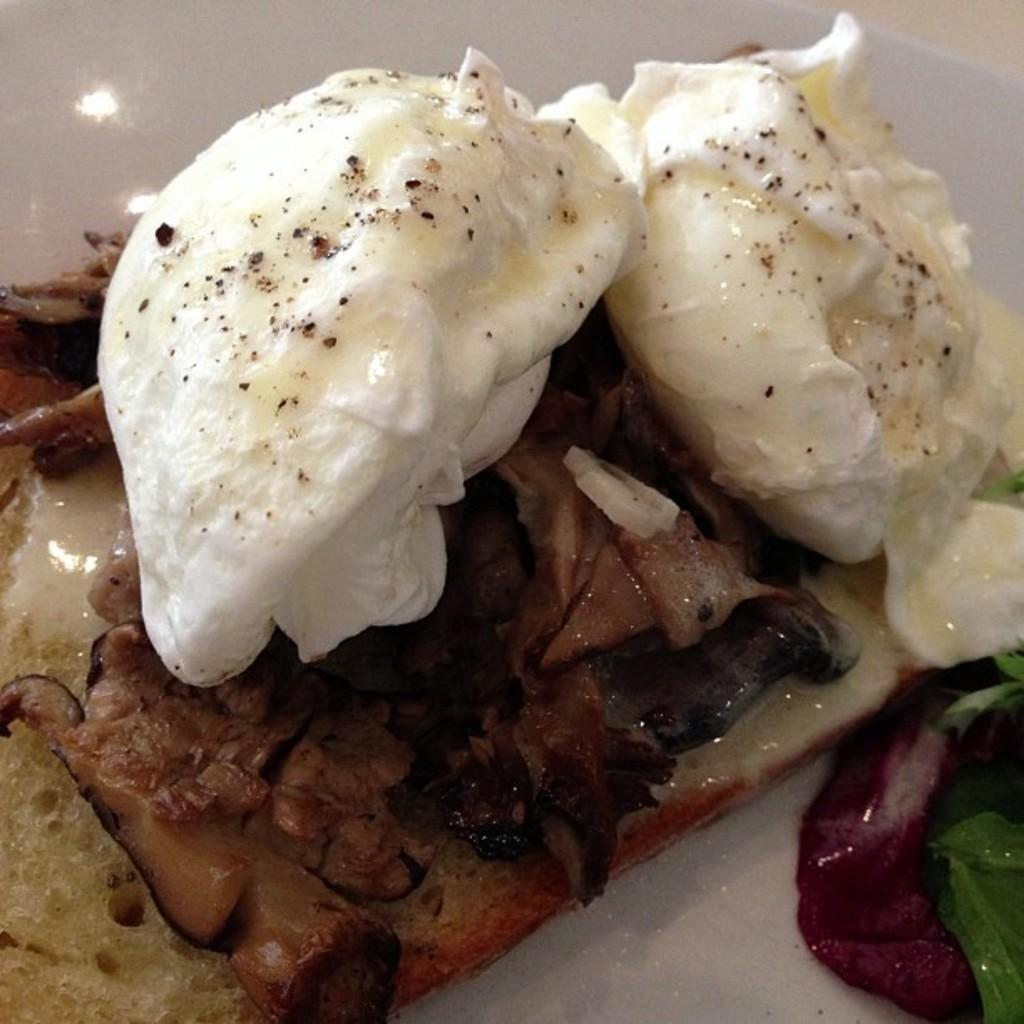What types of food can be seen in the image? There are different types of food in the image. Can you describe the colors of the food? The colors of the food include white, black, brown, green, and red. What type of toy can be seen playing with the food in the image? There is no toy present in the image, and the food is not being played with. 